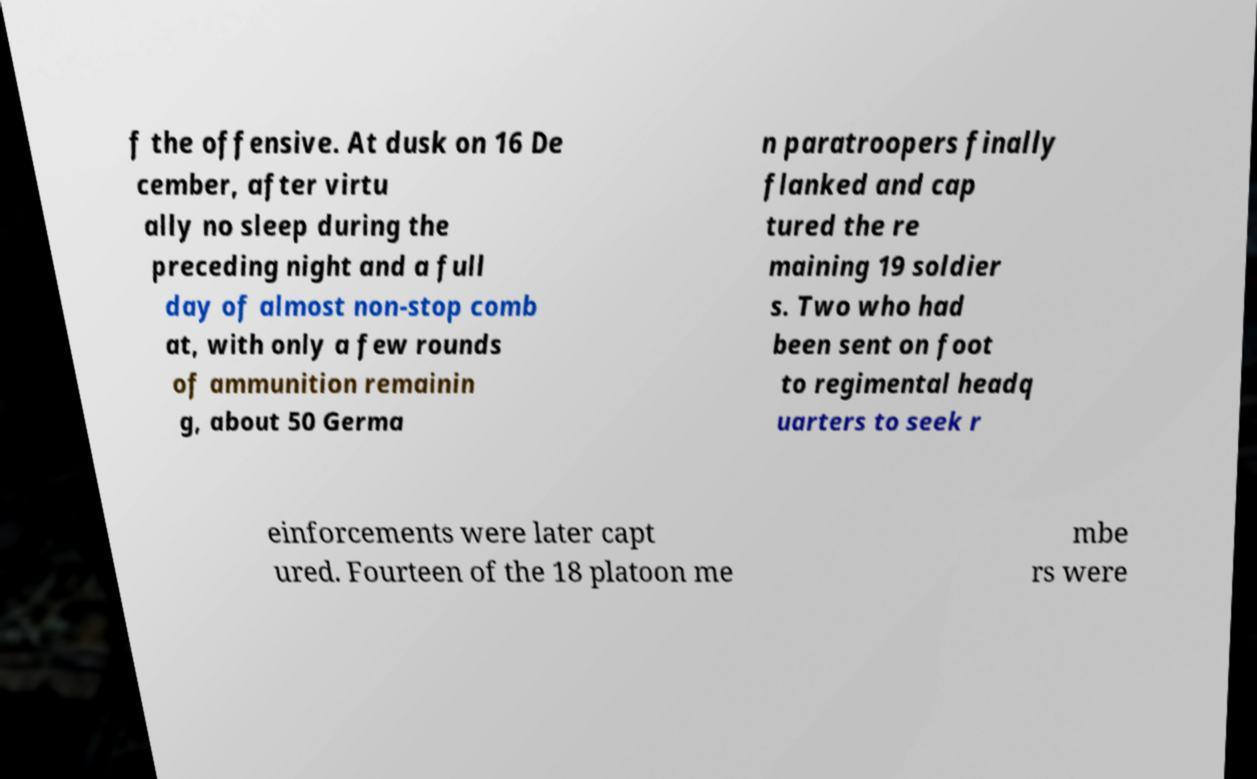What messages or text are displayed in this image? I need them in a readable, typed format. f the offensive. At dusk on 16 De cember, after virtu ally no sleep during the preceding night and a full day of almost non-stop comb at, with only a few rounds of ammunition remainin g, about 50 Germa n paratroopers finally flanked and cap tured the re maining 19 soldier s. Two who had been sent on foot to regimental headq uarters to seek r einforcements were later capt ured. Fourteen of the 18 platoon me mbe rs were 